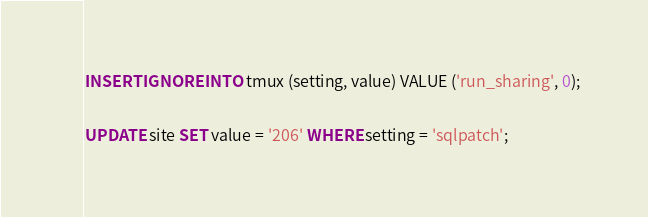Convert code to text. <code><loc_0><loc_0><loc_500><loc_500><_SQL_>INSERT IGNORE INTO tmux (setting, value) VALUE ('run_sharing', 0);

UPDATE site SET value = '206' WHERE setting = 'sqlpatch';
</code> 